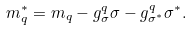<formula> <loc_0><loc_0><loc_500><loc_500>m _ { q } ^ { * } = m _ { q } - g ^ { q } _ { \sigma } \sigma - g ^ { q } _ { \sigma ^ { * } } \sigma ^ { * } .</formula> 